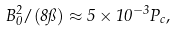Convert formula to latex. <formula><loc_0><loc_0><loc_500><loc_500>B _ { 0 } ^ { 2 } / ( 8 \pi ) \approx 5 \times 1 0 ^ { - 3 } P _ { c } ,</formula> 